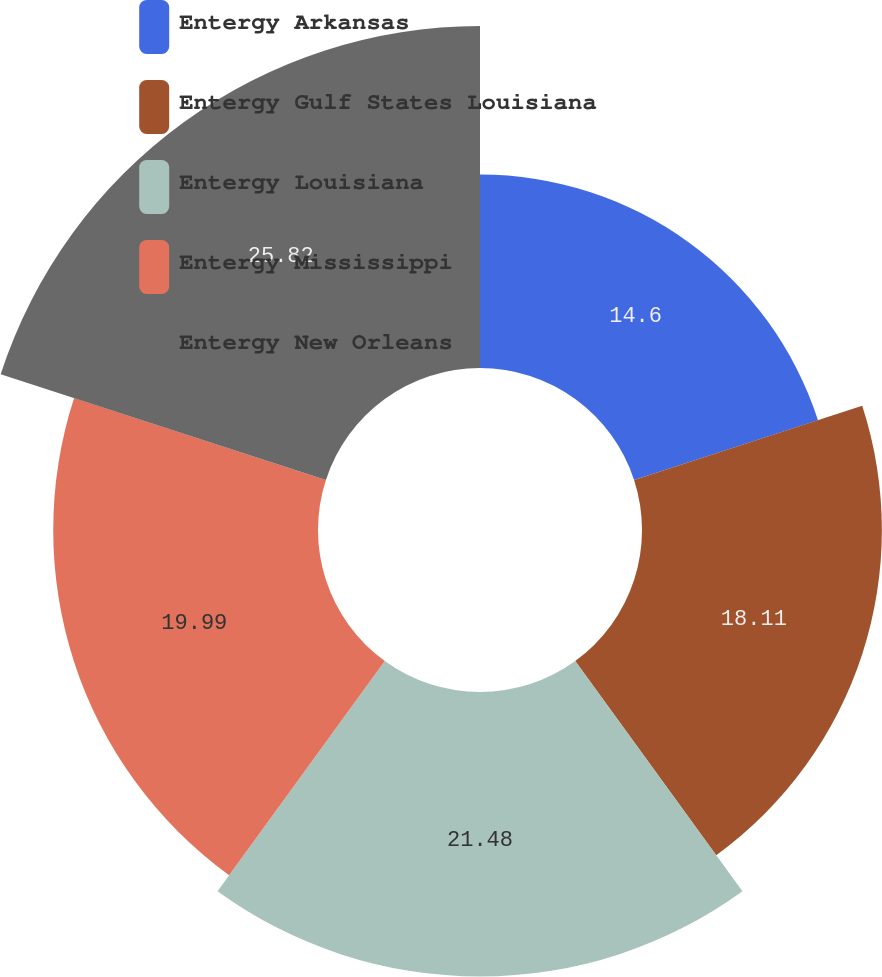<chart> <loc_0><loc_0><loc_500><loc_500><pie_chart><fcel>Entergy Arkansas<fcel>Entergy Gulf States Louisiana<fcel>Entergy Louisiana<fcel>Entergy Mississippi<fcel>Entergy New Orleans<nl><fcel>14.6%<fcel>18.11%<fcel>21.48%<fcel>19.99%<fcel>25.82%<nl></chart> 